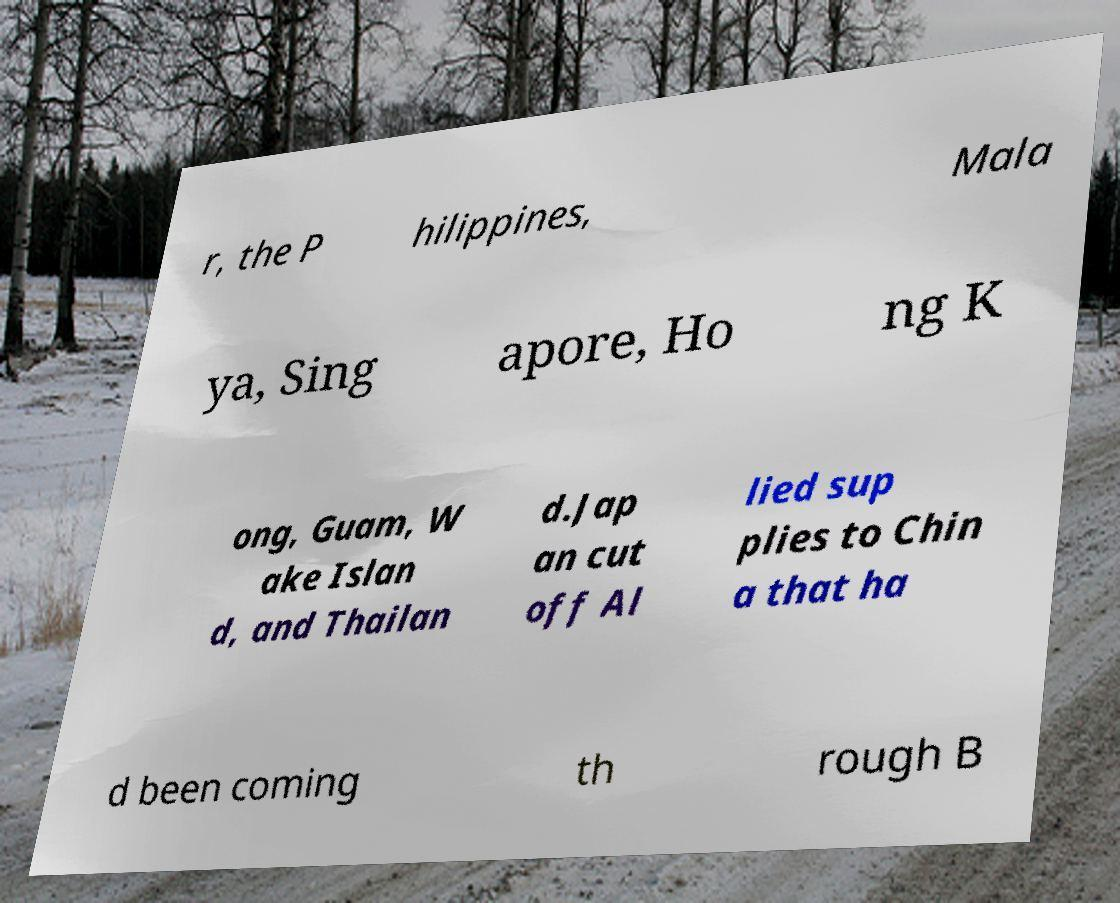There's text embedded in this image that I need extracted. Can you transcribe it verbatim? r, the P hilippines, Mala ya, Sing apore, Ho ng K ong, Guam, W ake Islan d, and Thailan d.Jap an cut off Al lied sup plies to Chin a that ha d been coming th rough B 